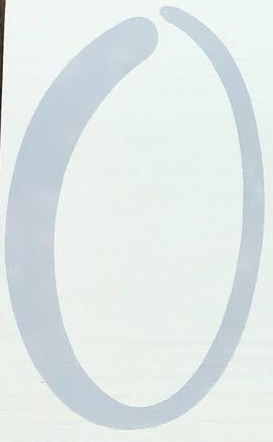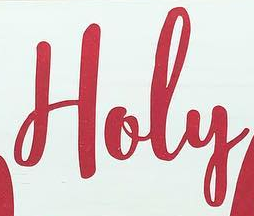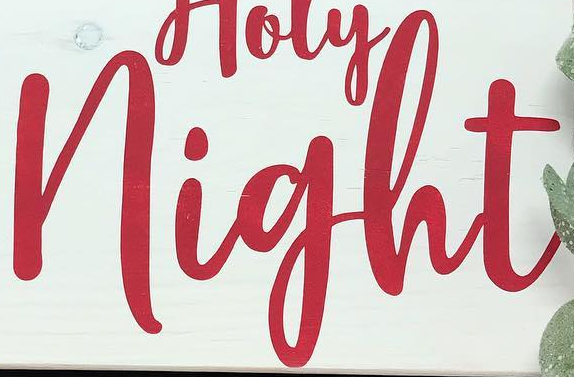What words can you see in these images in sequence, separated by a semicolon? O; Holy; night 